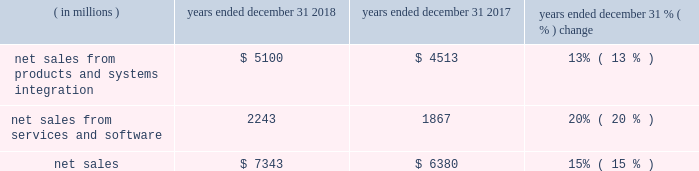Results of operations 20142018 compared to 2017 net sales .
The products and systems integration segment 2019s net sales represented 69% ( 69 % ) of our consolidated net sales in 2018 , compared to 71% ( 71 % ) in 2017 .
The services and software segment 2019s net sales represented 31% ( 31 % ) of our consolidated net sales in 2018 , compared to 29% ( 29 % ) in 2017 .
Net sales were up $ 963 million , or 15% ( 15 % ) , compared to 2017 .
The increase in net sales was driven by the americas and emea with a 13% ( 13 % ) increase in the products and systems integration segment and a 20% ( 20 % ) increase in the services and software segment .
This growth includes : 2022 $ 507 million of incremental revenue from the acquisitions of avigilon and plant in 2018 and kodiak networks and interexport which were acquired during 2017 ; 2022 $ 83 million from the adoption of accounting standards codification ( "asc" ) 606 ( see note 1 of our consolidated financial statements ) ; and 2022 $ 32 million from favorable currency rates .
Regional results include : 2022 the americas grew 17% ( 17 % ) across all products within both the products and systems integration and the services and software segments , inclusive of incremental revenue from acquisitions ; 2022 emea grew 18% ( 18 % ) on broad-based growth within all offerings within our products and systems integration and services and software segments , inclusive of incremental revenue from acquisitions ; and 2022 ap was relatively flat with growth in the services and software segment offset by lower products and systems integration revenue .
Products and systems integration the 13% ( 13 % ) growth in the products and systems integration segment was driven by the following : 2022 $ 318 million of incremental revenue from the acquisitions of avigilon in 2018 and interexport during 2017 ; 2022 $ 78 million from the adoption of asc 606 ; 2022 devices revenues were up significantly due to the acquisition of avigilon along with strong demand in the americas and emea ; and 2022 systems and systems integration revenues increased 10% ( 10 % ) in 2018 , as compared to 2017 driven by incremental revenue from avigilon , as well as system deployments in emea and ap .
Services and software the 20% ( 20 % ) growth in the services and software segment was driven by the following : 2022 $ 189 million of incremental revenue primarily from the acquisitions of plant and avigilon in 2018 and kodiak networks and interexport during 2017 ; 2022 $ 5 million from the adoption of asc 606 ; 2022 services were up $ 174 million , or 9% ( 9 % ) , driven by growth in both maintenance and managed service revenues , and incremental revenue from the acquisitions of interexport and plant ; and 2022 software was up $ 202 million , or 89% ( 89 % ) , driven primarily by incremental revenue from the acquisitions of plant , avigilon , and kodiak networks , and growth in our command center software suite. .
In 2018 what was the ratio of the net sales from products and systems integration to the services and software? 
Computations: (5100 / 2243)
Answer: 2.27374. 